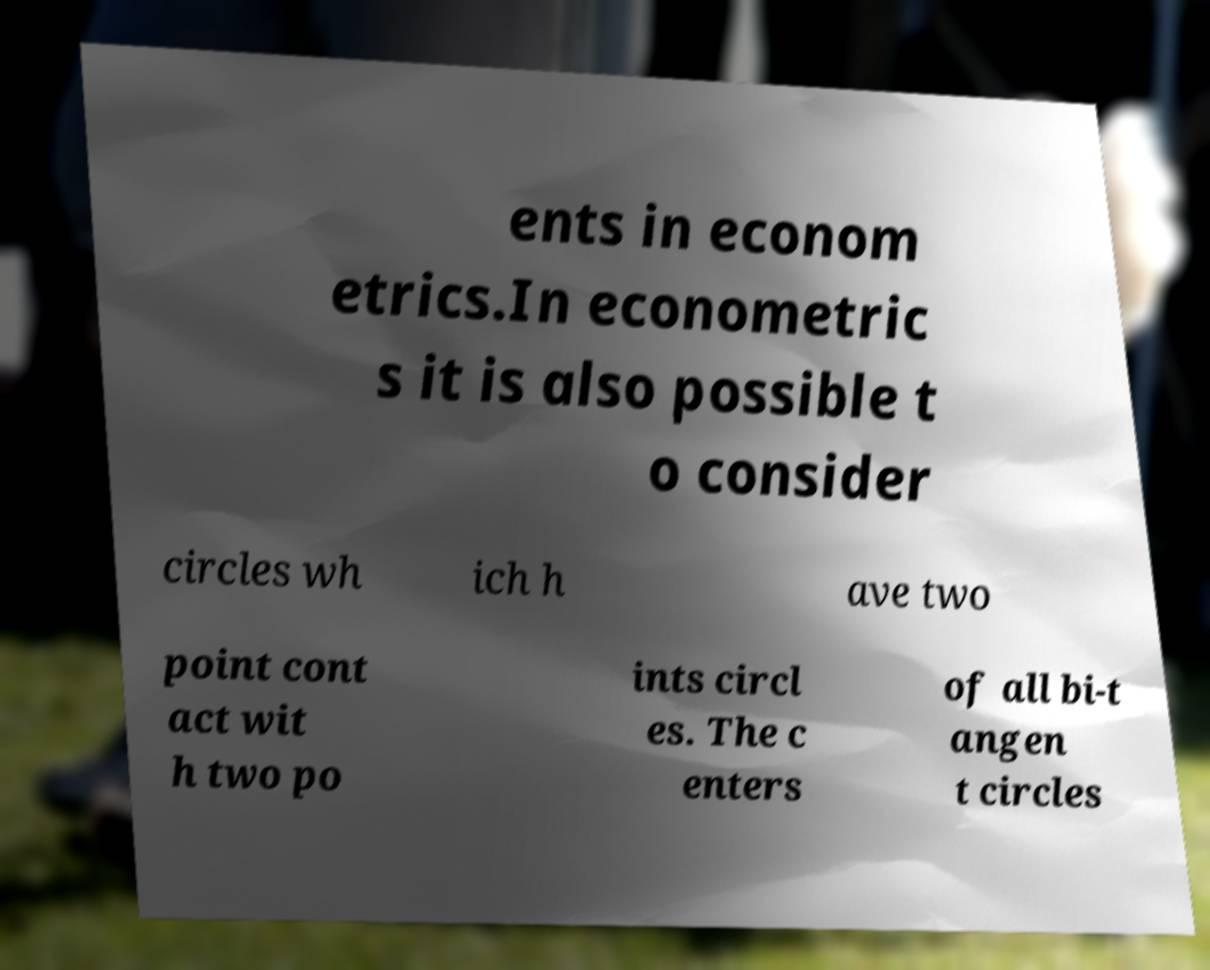Please identify and transcribe the text found in this image. ents in econom etrics.In econometric s it is also possible t o consider circles wh ich h ave two point cont act wit h two po ints circl es. The c enters of all bi-t angen t circles 